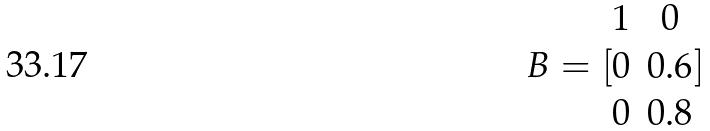Convert formula to latex. <formula><loc_0><loc_0><loc_500><loc_500>B = [ \begin{matrix} 1 & 0 \\ 0 & 0 . 6 \\ 0 & 0 . 8 \end{matrix} ]</formula> 